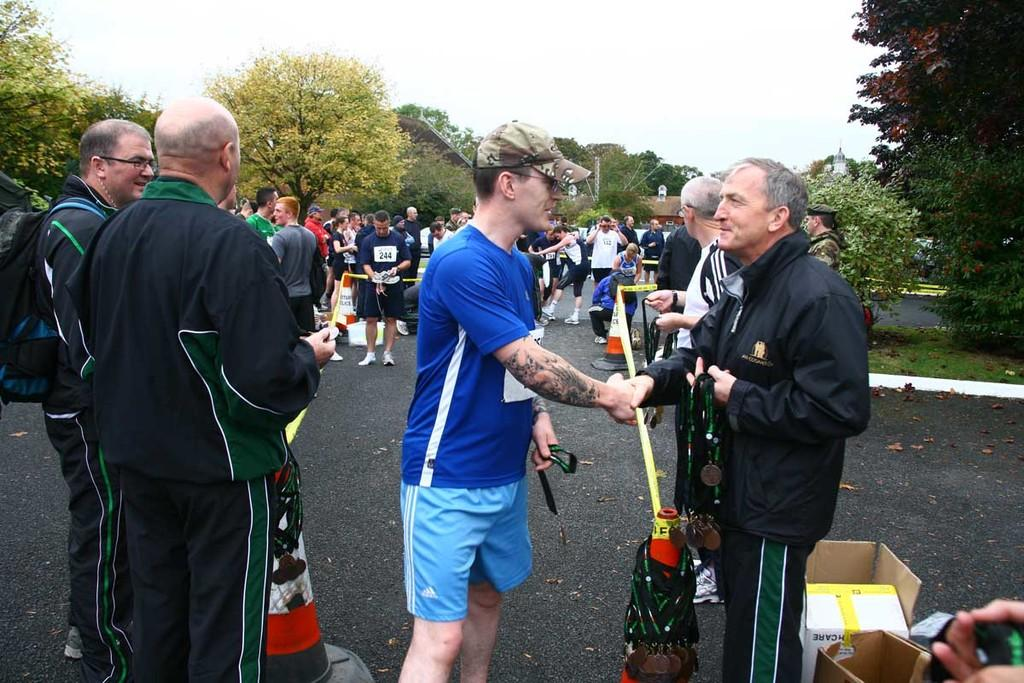What is happening on the road in the image? There are persons on the road in the image. What might be used to direct traffic or indicate a hazard in the image? Traffic cones are present in the image. What type of containers can be seen in the image? Cardboard cartons are visible in the image. What is the ground surface like in the image? The ground is visible in the image. What type of natural debris can be seen on the ground in the image? Shredded leaves are present in the image. What type of structures can be seen in the image? There are buildings in the image. What type of vertical structures can be seen in the image? Poles are visible in the image. What is visible above the ground in the image? The sky is visible in the image. What type of beast is being transported by the persons on the road in the image? There is no beast present in the image; the persons on the road are not shown transporting any animals. What process is being carried out by the traffic cones in the image? Traffic cones do not carry out any processes; they are inanimate objects used to direct traffic or indicate a hazard. 